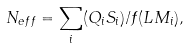<formula> <loc_0><loc_0><loc_500><loc_500>N _ { e f f } = \sum _ { i } ( Q _ { i } S _ { i } ) / f ( L M _ { i } ) ,</formula> 